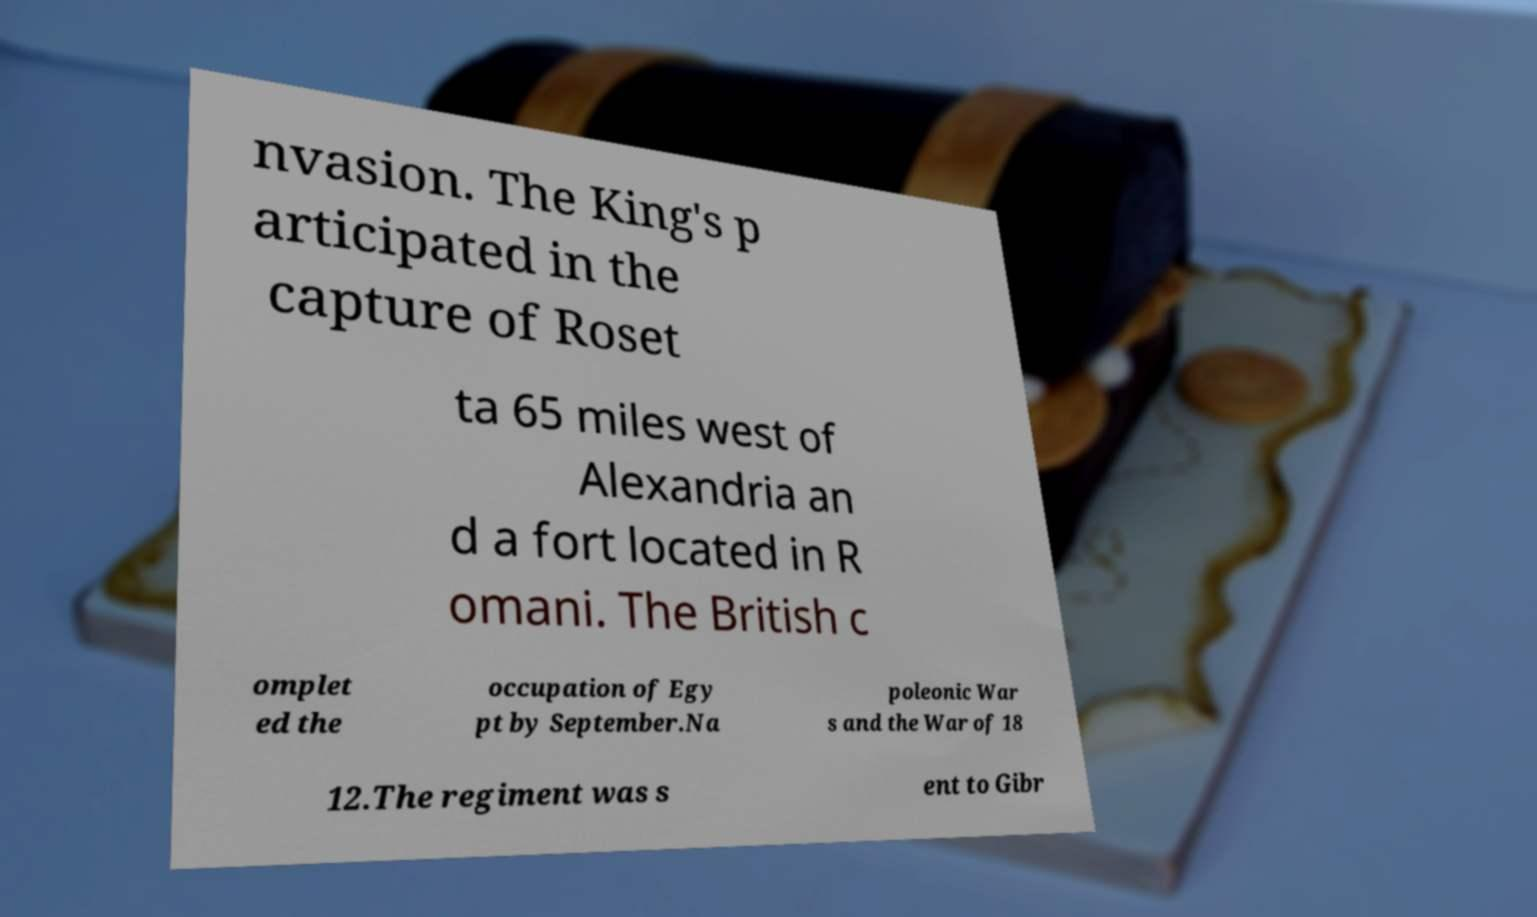Please read and relay the text visible in this image. What does it say? nvasion. The King's p articipated in the capture of Roset ta 65 miles west of Alexandria an d a fort located in R omani. The British c omplet ed the occupation of Egy pt by September.Na poleonic War s and the War of 18 12.The regiment was s ent to Gibr 